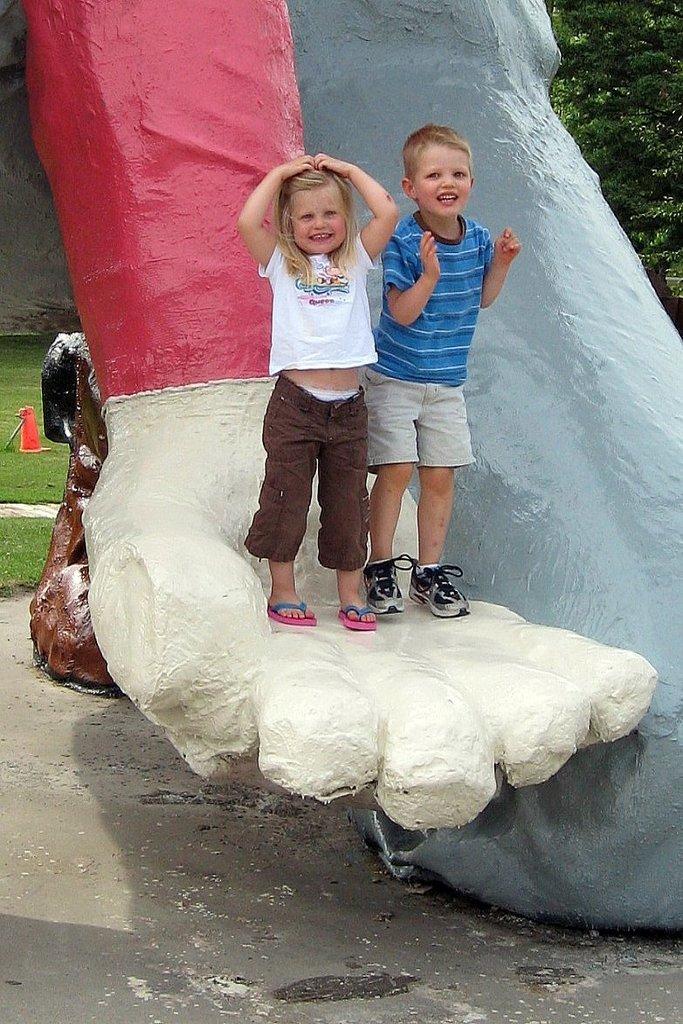Please provide a concise description of this image. This picture is clicked outside. In the center there is a girl smiling, wearing white color t-shirt and standing on the sculpture and there is a boy smiling, wearing blue color t-shirt and standing on the sculpture. In the background we can see the green grass and a tree and some other items. 